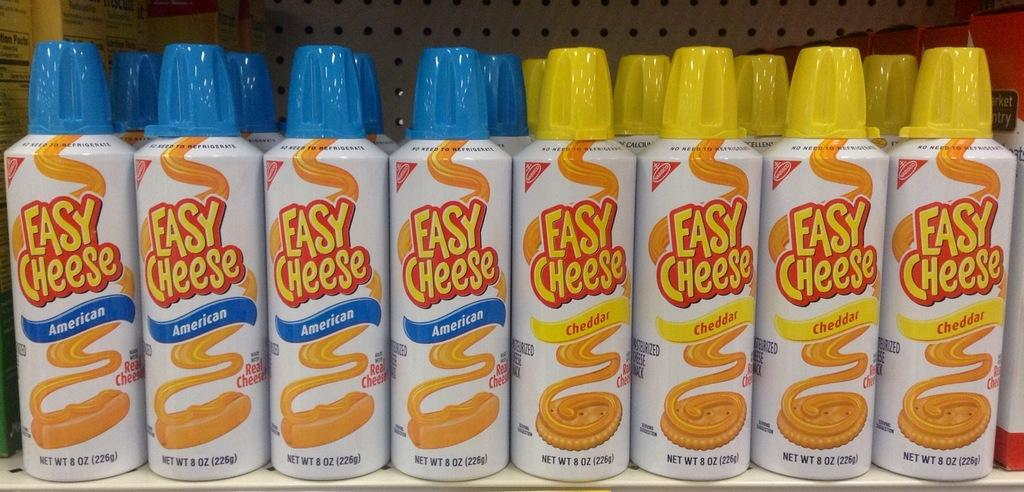<image>
Present a compact description of the photo's key features. rows and rows of easy cheese cans with blue and yellow lids 